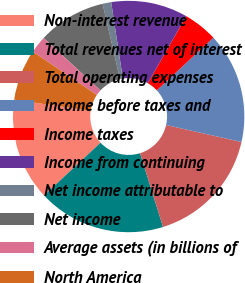<chart> <loc_0><loc_0><loc_500><loc_500><pie_chart><fcel>Non-interest revenue<fcel>Total revenues net of interest<fcel>Total operating expenses<fcel>Income before taxes and<fcel>Income taxes<fcel>Income from continuing<fcel>Net income attributable to<fcel>Net income<fcel>Average assets (in billions of<fcel>North America<nl><fcel>14.28%<fcel>17.85%<fcel>16.66%<fcel>15.47%<fcel>4.77%<fcel>10.71%<fcel>1.2%<fcel>9.52%<fcel>2.39%<fcel>7.15%<nl></chart> 